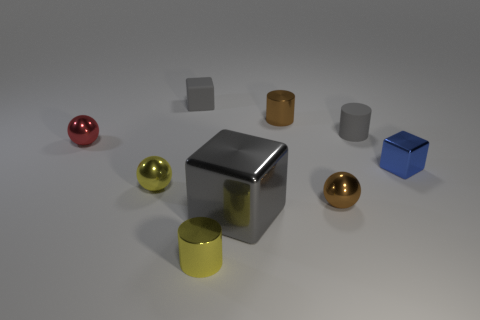Subtract all tiny red balls. How many balls are left? 2 Subtract all blue cylinders. How many gray cubes are left? 2 Subtract 1 cubes. How many cubes are left? 2 Add 1 tiny gray cylinders. How many objects exist? 10 Subtract all gray cubes. How many cubes are left? 1 Subtract all spheres. How many objects are left? 6 Subtract all blue balls. Subtract all brown cylinders. How many balls are left? 3 Add 8 yellow spheres. How many yellow spheres are left? 9 Add 7 blue rubber cylinders. How many blue rubber cylinders exist? 7 Subtract 0 cyan spheres. How many objects are left? 9 